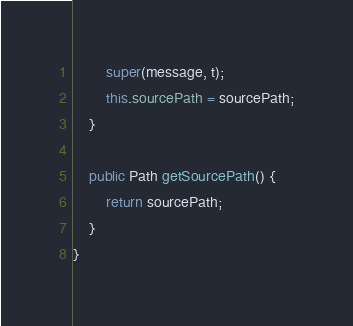Convert code to text. <code><loc_0><loc_0><loc_500><loc_500><_Java_>        super(message, t);
        this.sourcePath = sourcePath;
    }

    public Path getSourcePath() {
        return sourcePath;
    }
}
</code> 